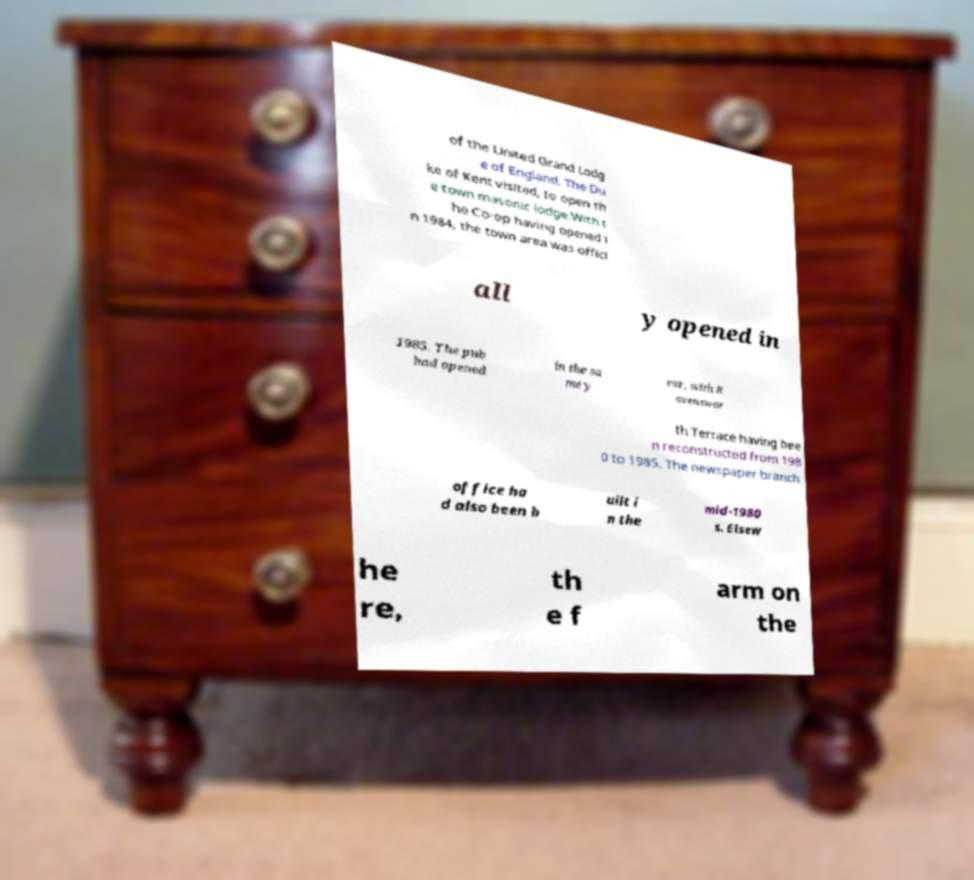There's text embedded in this image that I need extracted. Can you transcribe it verbatim? of the United Grand Lodg e of England, The Du ke of Kent visited, to open th e town masonic lodge.With t he Co-op having opened i n 1984, the town area was offici all y opened in 1985. The pub had opened in the sa me y ear, with R avenswor th Terrace having bee n reconstructed from 198 0 to 1985. The newspaper branch office ha d also been b uilt i n the mid-1980 s. Elsew he re, th e f arm on the 